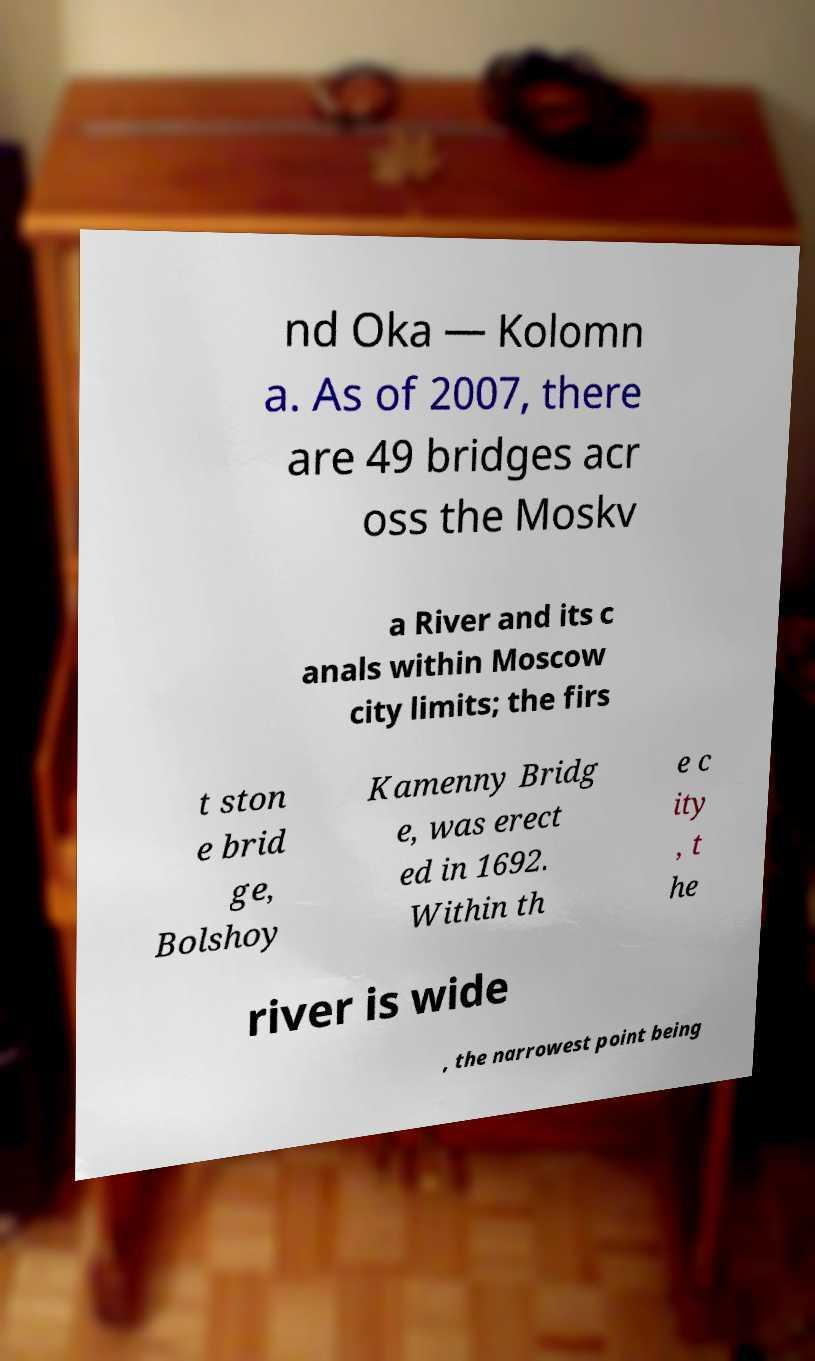What messages or text are displayed in this image? I need them in a readable, typed format. nd Oka — Kolomn a. As of 2007, there are 49 bridges acr oss the Moskv a River and its c anals within Moscow city limits; the firs t ston e brid ge, Bolshoy Kamenny Bridg e, was erect ed in 1692. Within th e c ity , t he river is wide , the narrowest point being 